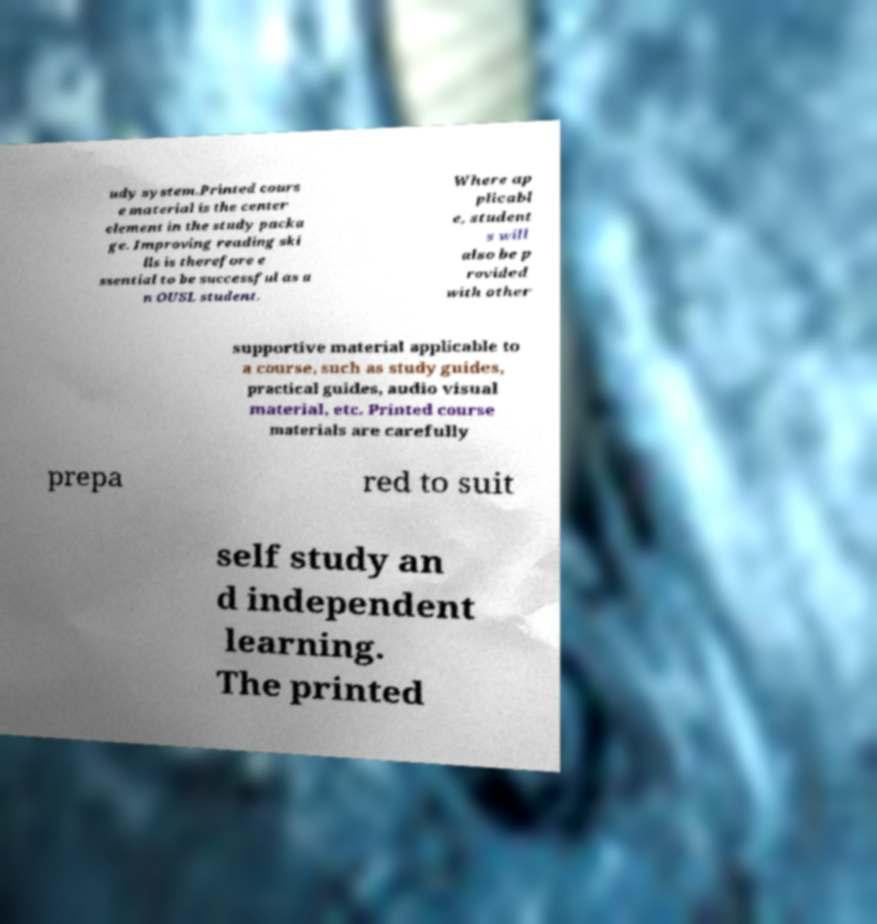What messages or text are displayed in this image? I need them in a readable, typed format. udy system.Printed cours e material is the center element in the study packa ge. Improving reading ski lls is therefore e ssential to be successful as a n OUSL student. Where ap plicabl e, student s will also be p rovided with other supportive material applicable to a course, such as study guides, practical guides, audio visual material, etc. Printed course materials are carefully prepa red to suit self study an d independent learning. The printed 